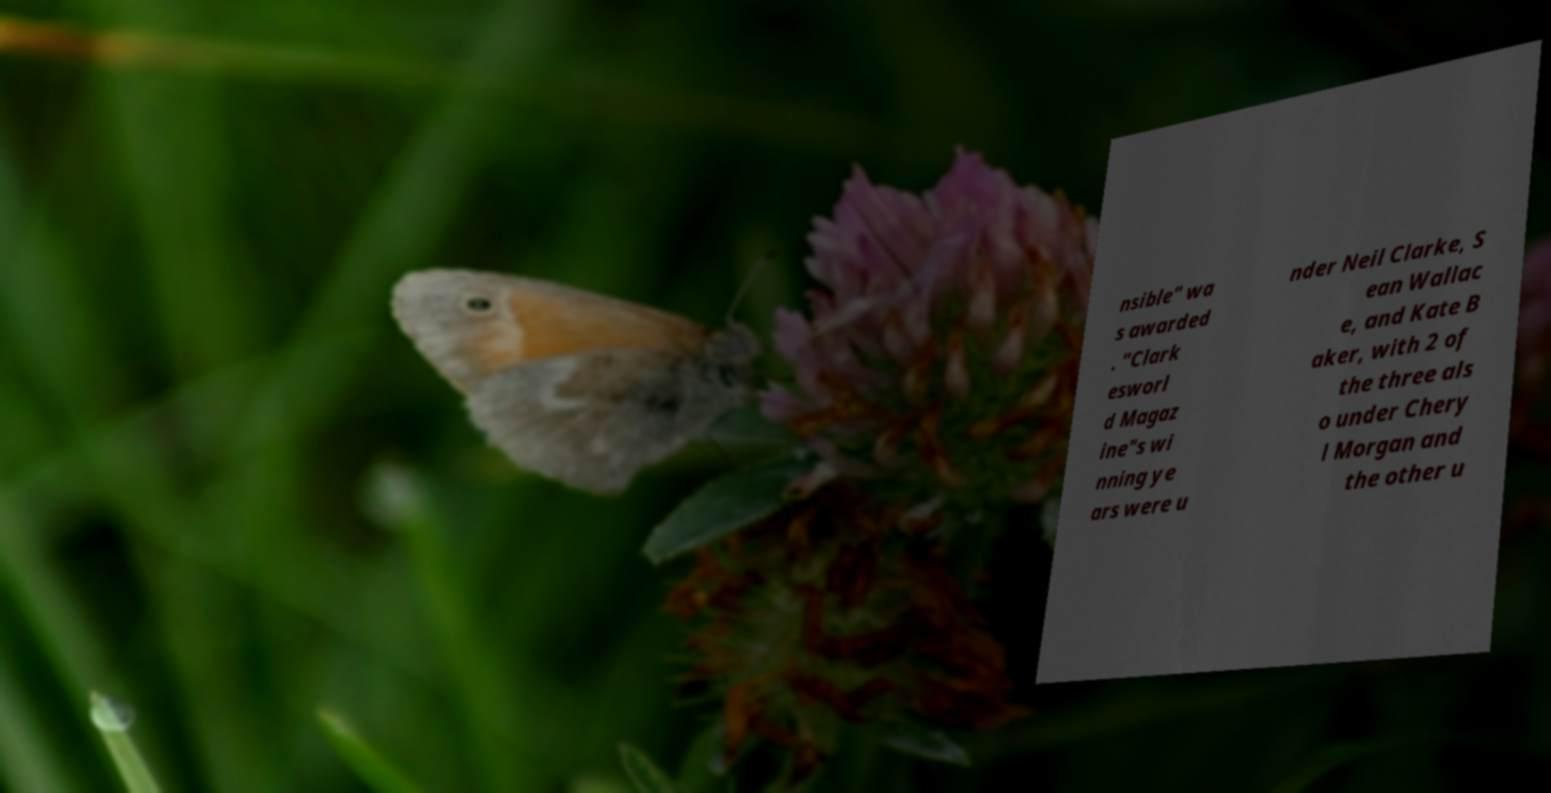There's text embedded in this image that I need extracted. Can you transcribe it verbatim? nsible" wa s awarded . "Clark esworl d Magaz ine"s wi nning ye ars were u nder Neil Clarke, S ean Wallac e, and Kate B aker, with 2 of the three als o under Chery l Morgan and the other u 